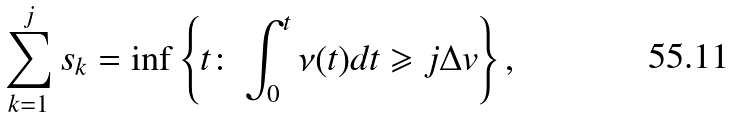<formula> <loc_0><loc_0><loc_500><loc_500>\sum _ { k = 1 } ^ { j } s _ { k } = \inf \left \{ t \colon \int _ { 0 } ^ { t } \nu ( t ) d t \geqslant j \Delta v \right \} ,</formula> 